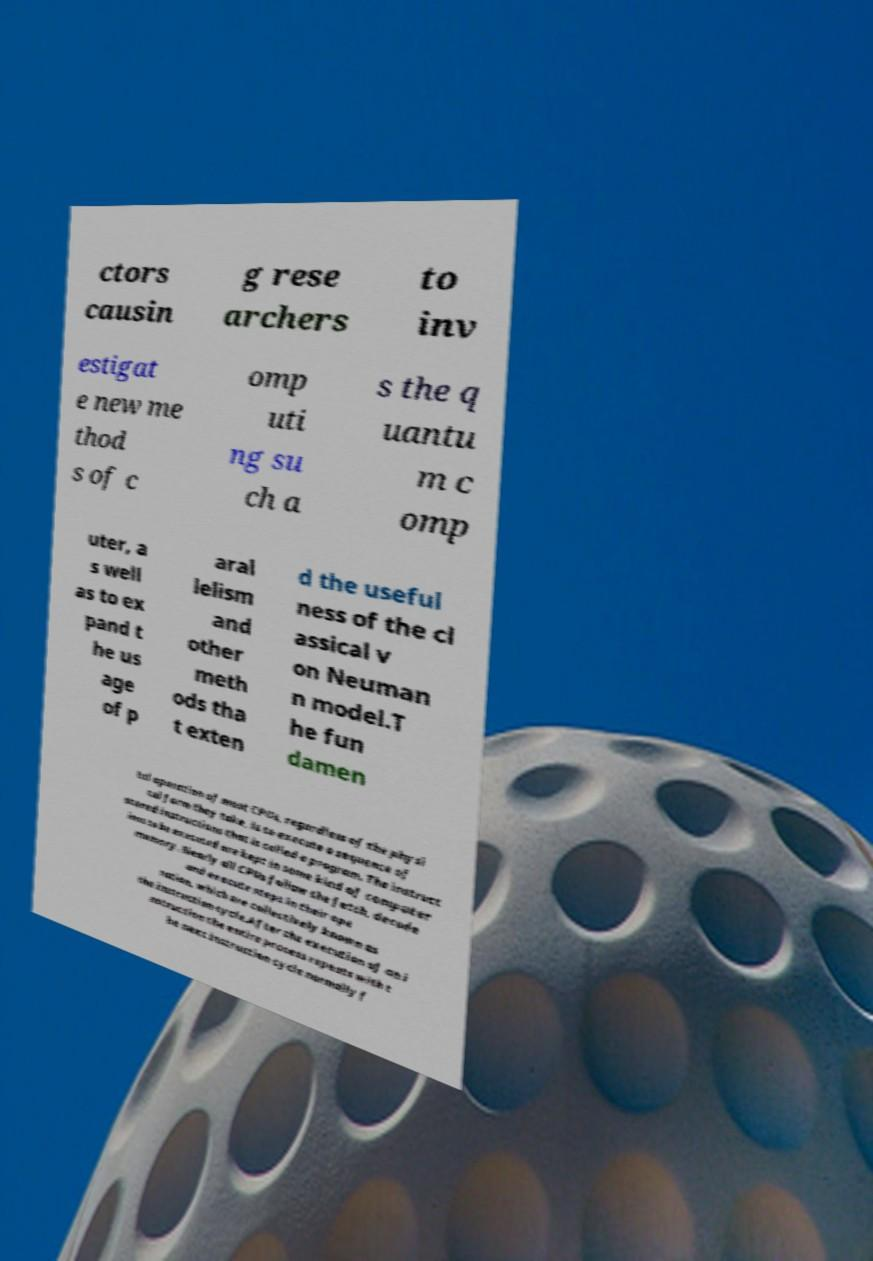Please identify and transcribe the text found in this image. ctors causin g rese archers to inv estigat e new me thod s of c omp uti ng su ch a s the q uantu m c omp uter, a s well as to ex pand t he us age of p aral lelism and other meth ods tha t exten d the useful ness of the cl assical v on Neuman n model.T he fun damen tal operation of most CPUs, regardless of the physi cal form they take, is to execute a sequence of stored instructions that is called a program. The instruct ions to be executed are kept in some kind of computer memory. Nearly all CPUs follow the fetch, decode and execute steps in their ope ration, which are collectively known as the instruction cycle.After the execution of an i nstruction the entire process repeats with t he next instruction cycle normally f 